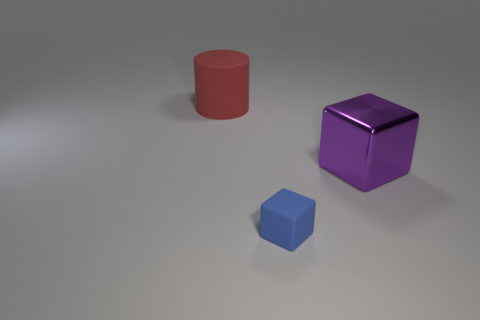Is the shape of the big metallic thing the same as the tiny thing? Both objects seem to have geometric shapes, but they are not the same. The larger object appears to be a cylinder, while the smaller object is a cube. Their sizes are notably different, and each has a distinct number of faces and edges, making their shapes unique from one another. 